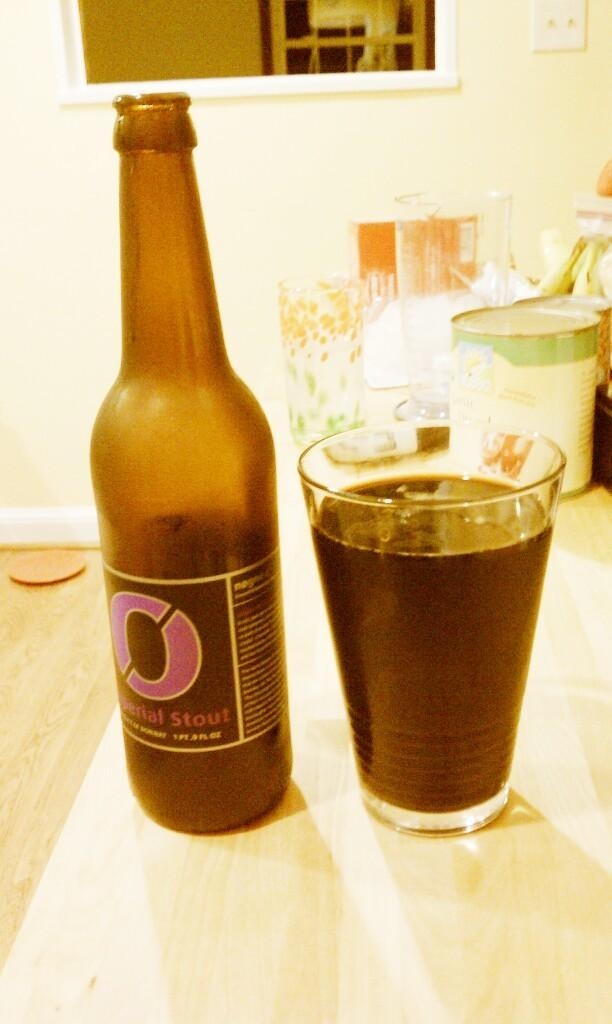<image>
Relay a brief, clear account of the picture shown. A full glass is to the right of a 1 PT .9 fl oz bottle of Stout. 